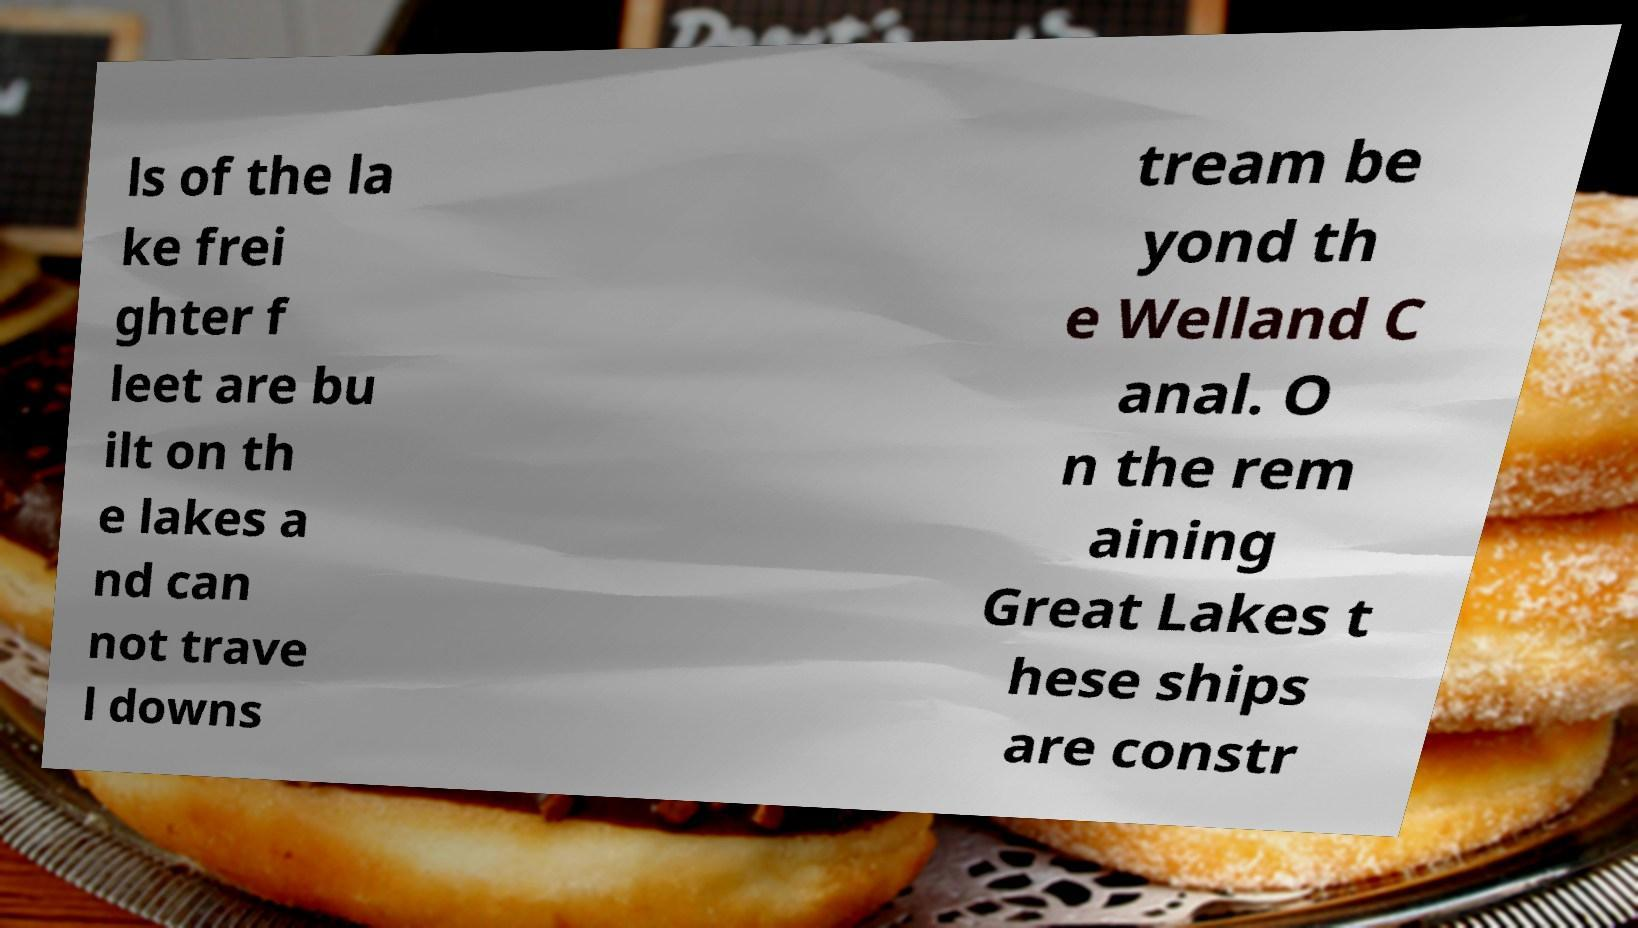I need the written content from this picture converted into text. Can you do that? ls of the la ke frei ghter f leet are bu ilt on th e lakes a nd can not trave l downs tream be yond th e Welland C anal. O n the rem aining Great Lakes t hese ships are constr 